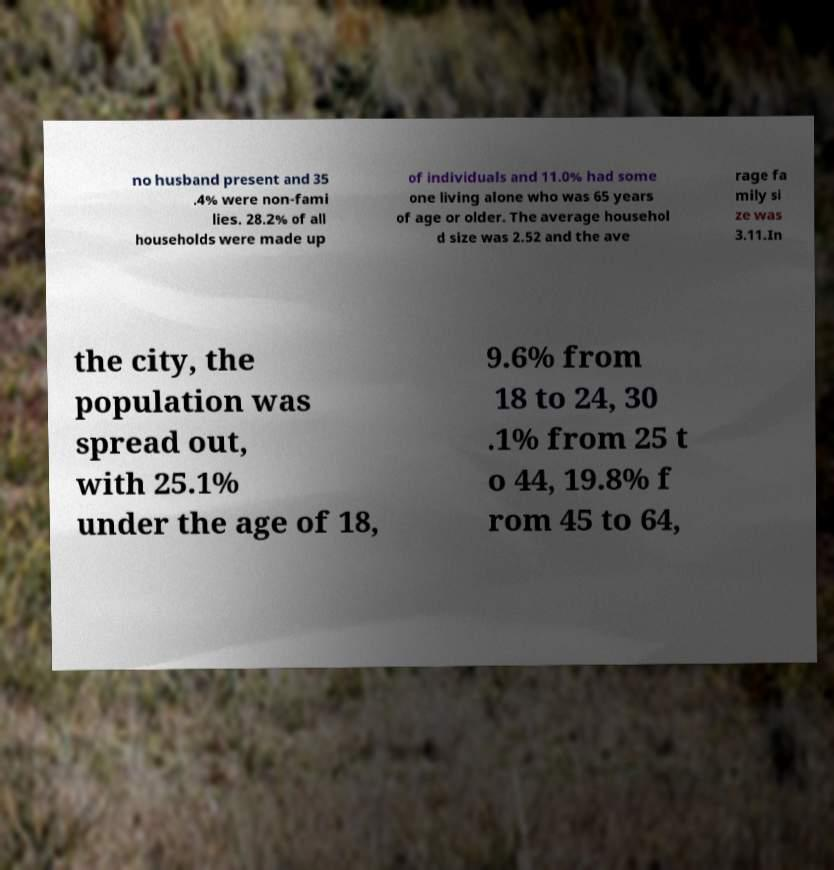Can you read and provide the text displayed in the image?This photo seems to have some interesting text. Can you extract and type it out for me? no husband present and 35 .4% were non-fami lies. 28.2% of all households were made up of individuals and 11.0% had some one living alone who was 65 years of age or older. The average househol d size was 2.52 and the ave rage fa mily si ze was 3.11.In the city, the population was spread out, with 25.1% under the age of 18, 9.6% from 18 to 24, 30 .1% from 25 t o 44, 19.8% f rom 45 to 64, 